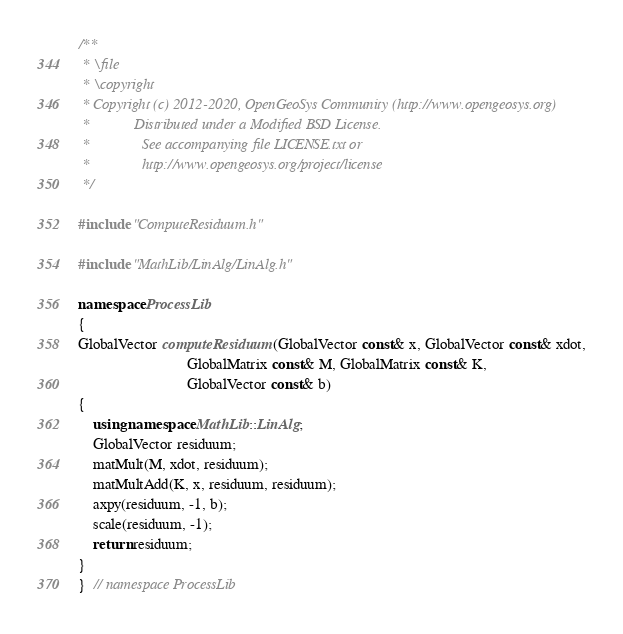<code> <loc_0><loc_0><loc_500><loc_500><_C++_>/**
 * \file
 * \copyright
 * Copyright (c) 2012-2020, OpenGeoSys Community (http://www.opengeosys.org)
 *            Distributed under a Modified BSD License.
 *              See accompanying file LICENSE.txt or
 *              http://www.opengeosys.org/project/license
 */

#include "ComputeResiduum.h"

#include "MathLib/LinAlg/LinAlg.h"

namespace ProcessLib
{
GlobalVector computeResiduum(GlobalVector const& x, GlobalVector const& xdot,
                             GlobalMatrix const& M, GlobalMatrix const& K,
                             GlobalVector const& b)
{
    using namespace MathLib::LinAlg;
    GlobalVector residuum;
    matMult(M, xdot, residuum);
    matMultAdd(K, x, residuum, residuum);
    axpy(residuum, -1, b);
    scale(residuum, -1);
    return residuum;
}
}  // namespace ProcessLib
</code> 